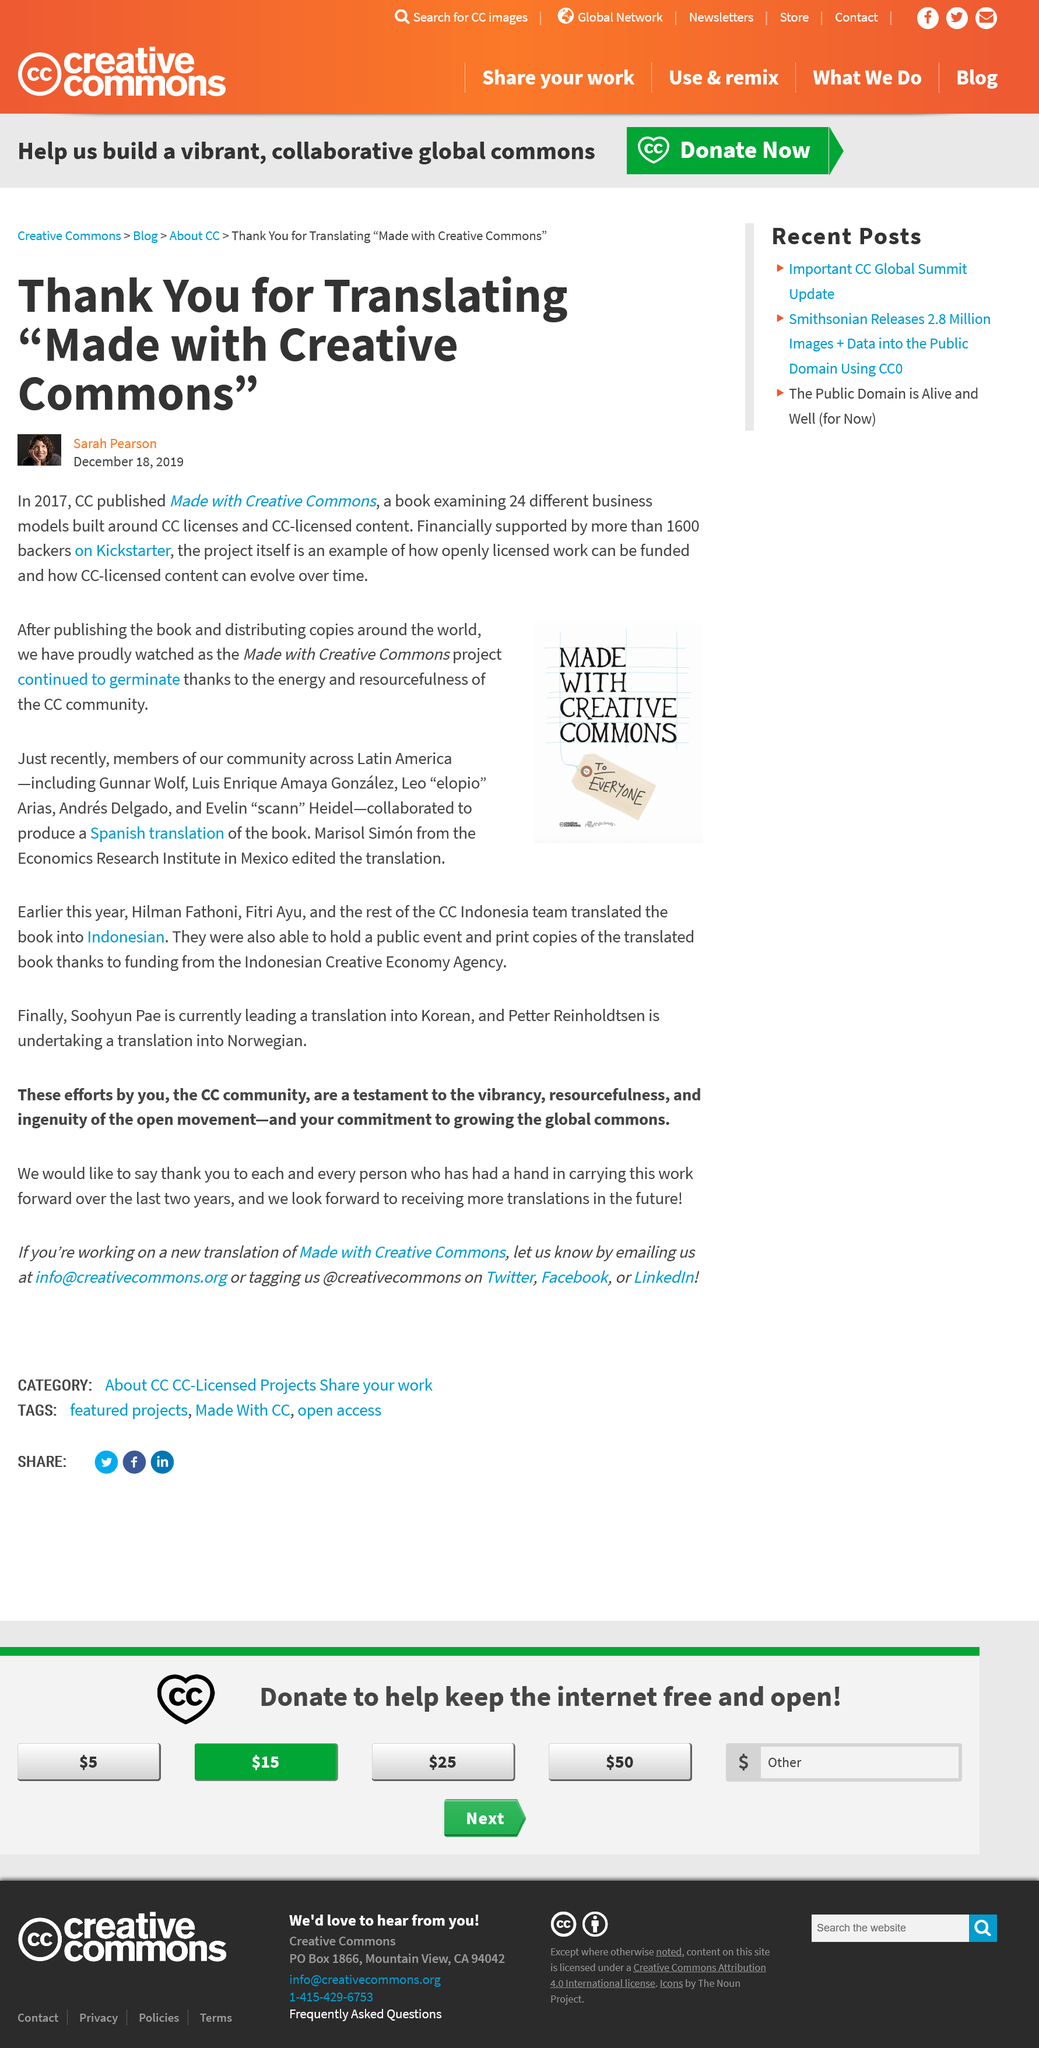Outline some significant characteristics in this image. Six people collaborated on the Spanish translation of the book. The author praises the energy and resourcefulness of the CC community. The book examined a total of 24 different business models. Marisol Simón edited the Spanish translation. CC published "Made with Creative Commons" two years prior to the publication of this article. 